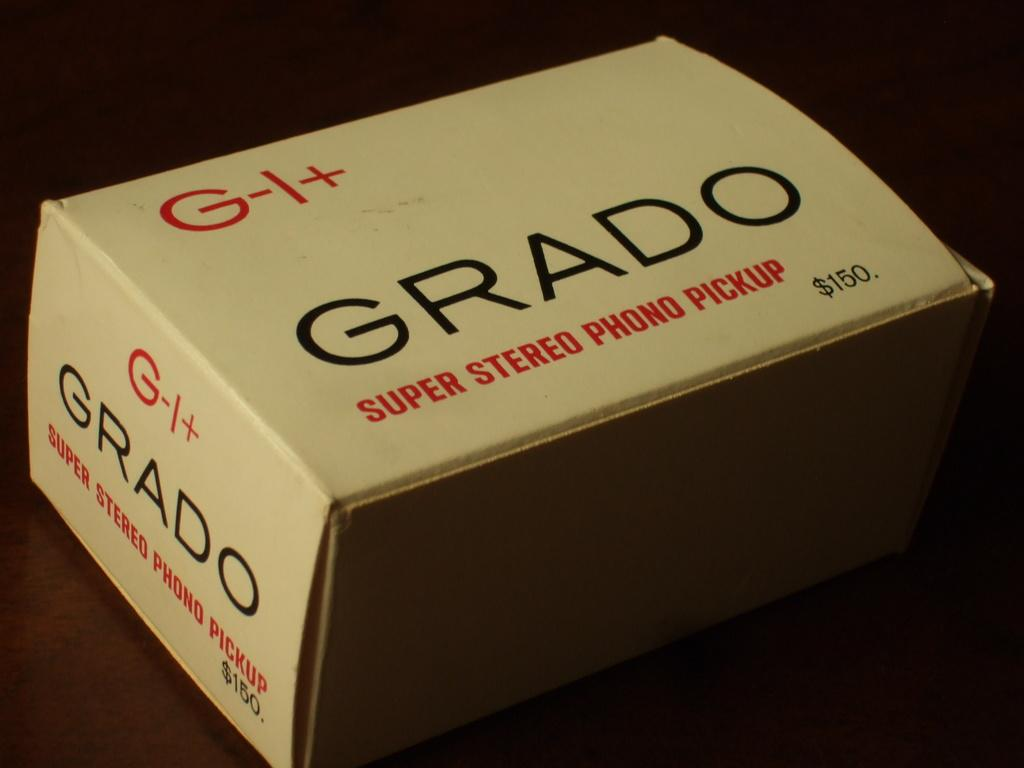Provide a one-sentence caption for the provided image. Box labeld GRADO SUPER STEREO PHONO PICKUP price is $150. 